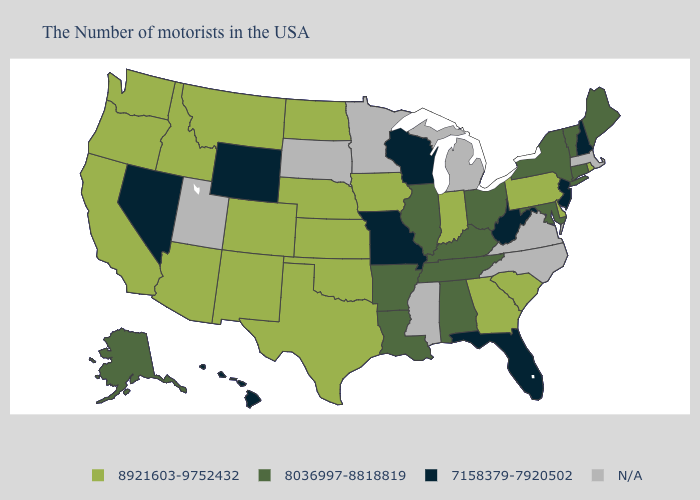Name the states that have a value in the range 8921603-9752432?
Keep it brief. Rhode Island, Delaware, Pennsylvania, South Carolina, Georgia, Indiana, Iowa, Kansas, Nebraska, Oklahoma, Texas, North Dakota, Colorado, New Mexico, Montana, Arizona, Idaho, California, Washington, Oregon. What is the value of Georgia?
Give a very brief answer. 8921603-9752432. What is the highest value in states that border New Mexico?
Write a very short answer. 8921603-9752432. Does the first symbol in the legend represent the smallest category?
Quick response, please. No. What is the value of Vermont?
Short answer required. 8036997-8818819. Does Vermont have the highest value in the USA?
Write a very short answer. No. Name the states that have a value in the range 8036997-8818819?
Be succinct. Maine, Vermont, Connecticut, New York, Maryland, Ohio, Kentucky, Alabama, Tennessee, Illinois, Louisiana, Arkansas, Alaska. How many symbols are there in the legend?
Concise answer only. 4. Name the states that have a value in the range 7158379-7920502?
Give a very brief answer. New Hampshire, New Jersey, West Virginia, Florida, Wisconsin, Missouri, Wyoming, Nevada, Hawaii. What is the value of Connecticut?
Short answer required. 8036997-8818819. How many symbols are there in the legend?
Be succinct. 4. What is the highest value in the South ?
Give a very brief answer. 8921603-9752432. Which states have the highest value in the USA?
Write a very short answer. Rhode Island, Delaware, Pennsylvania, South Carolina, Georgia, Indiana, Iowa, Kansas, Nebraska, Oklahoma, Texas, North Dakota, Colorado, New Mexico, Montana, Arizona, Idaho, California, Washington, Oregon. Name the states that have a value in the range 8921603-9752432?
Write a very short answer. Rhode Island, Delaware, Pennsylvania, South Carolina, Georgia, Indiana, Iowa, Kansas, Nebraska, Oklahoma, Texas, North Dakota, Colorado, New Mexico, Montana, Arizona, Idaho, California, Washington, Oregon. Name the states that have a value in the range 7158379-7920502?
Give a very brief answer. New Hampshire, New Jersey, West Virginia, Florida, Wisconsin, Missouri, Wyoming, Nevada, Hawaii. 